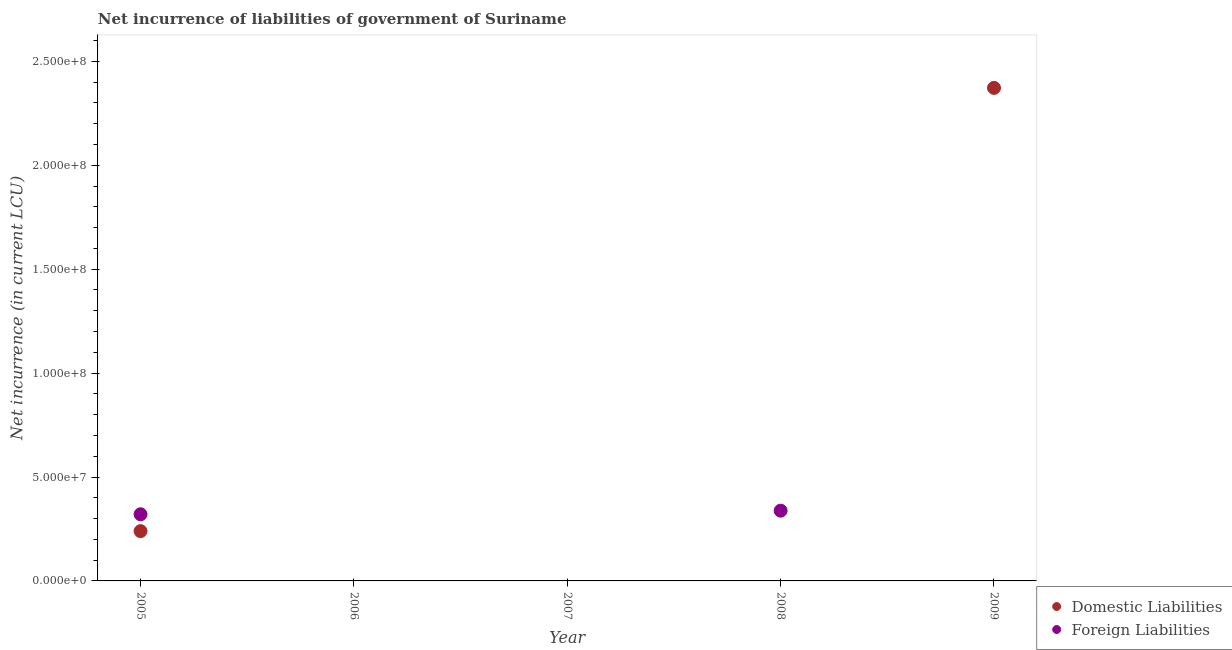How many different coloured dotlines are there?
Offer a very short reply. 2. What is the net incurrence of foreign liabilities in 2009?
Keep it short and to the point. 0. Across all years, what is the maximum net incurrence of foreign liabilities?
Your response must be concise. 3.38e+07. What is the total net incurrence of domestic liabilities in the graph?
Your answer should be very brief. 2.61e+08. What is the difference between the net incurrence of foreign liabilities in 2006 and the net incurrence of domestic liabilities in 2005?
Your answer should be compact. -2.40e+07. What is the average net incurrence of foreign liabilities per year?
Your response must be concise. 1.32e+07. In the year 2005, what is the difference between the net incurrence of domestic liabilities and net incurrence of foreign liabilities?
Make the answer very short. -8.12e+06. In how many years, is the net incurrence of domestic liabilities greater than 220000000 LCU?
Offer a very short reply. 1. Is the net incurrence of foreign liabilities in 2005 less than that in 2008?
Make the answer very short. Yes. What is the difference between the highest and the lowest net incurrence of foreign liabilities?
Your answer should be very brief. 3.38e+07. In how many years, is the net incurrence of domestic liabilities greater than the average net incurrence of domestic liabilities taken over all years?
Provide a short and direct response. 1. Is the net incurrence of domestic liabilities strictly greater than the net incurrence of foreign liabilities over the years?
Keep it short and to the point. No. Is the net incurrence of foreign liabilities strictly less than the net incurrence of domestic liabilities over the years?
Provide a succinct answer. No. What is the difference between two consecutive major ticks on the Y-axis?
Your response must be concise. 5.00e+07. Are the values on the major ticks of Y-axis written in scientific E-notation?
Offer a terse response. Yes. Does the graph contain any zero values?
Make the answer very short. Yes. Does the graph contain grids?
Provide a short and direct response. No. What is the title of the graph?
Your response must be concise. Net incurrence of liabilities of government of Suriname. Does "Malaria" appear as one of the legend labels in the graph?
Ensure brevity in your answer.  No. What is the label or title of the X-axis?
Give a very brief answer. Year. What is the label or title of the Y-axis?
Give a very brief answer. Net incurrence (in current LCU). What is the Net incurrence (in current LCU) in Domestic Liabilities in 2005?
Provide a succinct answer. 2.40e+07. What is the Net incurrence (in current LCU) in Foreign Liabilities in 2005?
Keep it short and to the point. 3.21e+07. What is the Net incurrence (in current LCU) of Foreign Liabilities in 2006?
Your answer should be very brief. 0. What is the Net incurrence (in current LCU) of Domestic Liabilities in 2007?
Provide a succinct answer. 0. What is the Net incurrence (in current LCU) in Foreign Liabilities in 2007?
Give a very brief answer. 0. What is the Net incurrence (in current LCU) in Foreign Liabilities in 2008?
Your answer should be compact. 3.38e+07. What is the Net incurrence (in current LCU) of Domestic Liabilities in 2009?
Offer a very short reply. 2.37e+08. Across all years, what is the maximum Net incurrence (in current LCU) in Domestic Liabilities?
Provide a succinct answer. 2.37e+08. Across all years, what is the maximum Net incurrence (in current LCU) in Foreign Liabilities?
Your response must be concise. 3.38e+07. Across all years, what is the minimum Net incurrence (in current LCU) of Domestic Liabilities?
Ensure brevity in your answer.  0. What is the total Net incurrence (in current LCU) of Domestic Liabilities in the graph?
Provide a succinct answer. 2.61e+08. What is the total Net incurrence (in current LCU) in Foreign Liabilities in the graph?
Your answer should be very brief. 6.59e+07. What is the difference between the Net incurrence (in current LCU) of Foreign Liabilities in 2005 and that in 2008?
Your answer should be compact. -1.72e+06. What is the difference between the Net incurrence (in current LCU) in Domestic Liabilities in 2005 and that in 2009?
Provide a short and direct response. -2.13e+08. What is the difference between the Net incurrence (in current LCU) of Domestic Liabilities in 2005 and the Net incurrence (in current LCU) of Foreign Liabilities in 2008?
Provide a short and direct response. -9.84e+06. What is the average Net incurrence (in current LCU) of Domestic Liabilities per year?
Your response must be concise. 5.22e+07. What is the average Net incurrence (in current LCU) of Foreign Liabilities per year?
Ensure brevity in your answer.  1.32e+07. In the year 2005, what is the difference between the Net incurrence (in current LCU) of Domestic Liabilities and Net incurrence (in current LCU) of Foreign Liabilities?
Your response must be concise. -8.12e+06. What is the ratio of the Net incurrence (in current LCU) in Foreign Liabilities in 2005 to that in 2008?
Your response must be concise. 0.95. What is the ratio of the Net incurrence (in current LCU) in Domestic Liabilities in 2005 to that in 2009?
Give a very brief answer. 0.1. What is the difference between the highest and the lowest Net incurrence (in current LCU) in Domestic Liabilities?
Your answer should be compact. 2.37e+08. What is the difference between the highest and the lowest Net incurrence (in current LCU) in Foreign Liabilities?
Provide a succinct answer. 3.38e+07. 